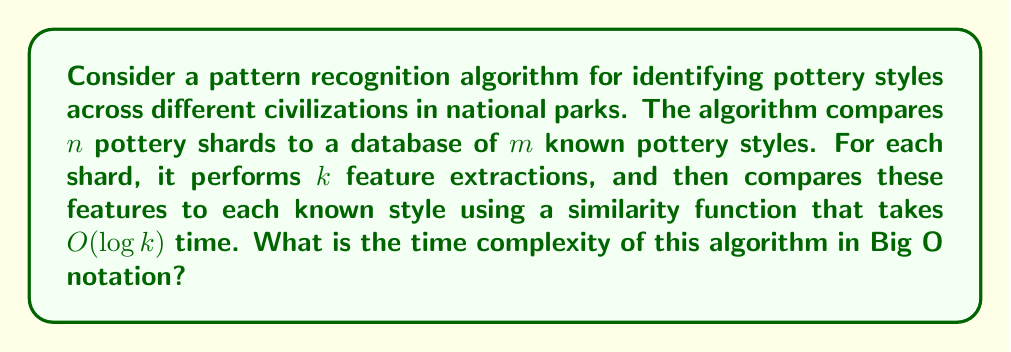Solve this math problem. To determine the time complexity of this algorithm, let's break it down step by step:

1. The algorithm processes $n$ pottery shards.

2. For each shard, it performs $k$ feature extractions. Assuming each feature extraction takes constant time, this step has a complexity of $O(k)$ for each shard.

3. After extracting features, each shard is compared to $m$ known pottery styles in the database.

4. For each comparison, a similarity function is used that takes $O(\log k)$ time.

5. Therefore, for a single shard, the time complexity is:
   $O(k)$ (for feature extraction) + $O(m \cdot \log k)$ (for comparisons)
   = $O(k + m \log k)$

6. Since this process is repeated for all $n$ shards, the total time complexity is:
   $O(n \cdot (k + m \log k))$

7. Expanding this expression:
   $O(nk + nm \log k)$

This is the final time complexity of the algorithm.

Note: In practice, the values of $k$ (number of features) and $m$ (number of known styles) might be considered constants if they don't grow with the input size $n$. In that case, the time complexity would simplify to $O(n)$. However, in this analysis, we're considering the general case where all variables can potentially grow.
Answer: $O(nk + nm \log k)$ 